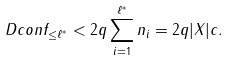<formula> <loc_0><loc_0><loc_500><loc_500>\ D c o n f _ { \leq \ell ^ { * } } < 2 q \sum _ { i = 1 } ^ { \ell ^ { * } } n _ { i } = 2 q | X | c .</formula> 